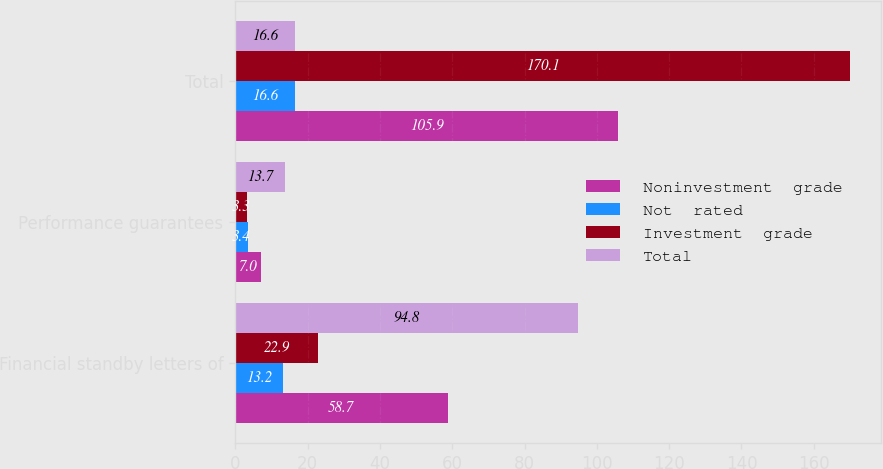<chart> <loc_0><loc_0><loc_500><loc_500><stacked_bar_chart><ecel><fcel>Financial standby letters of<fcel>Performance guarantees<fcel>Total<nl><fcel>Noninvestment  grade<fcel>58.7<fcel>7<fcel>105.9<nl><fcel>Not  rated<fcel>13.2<fcel>3.4<fcel>16.6<nl><fcel>Investment  grade<fcel>22.9<fcel>3.3<fcel>170.1<nl><fcel>Total<fcel>94.8<fcel>13.7<fcel>16.6<nl></chart> 